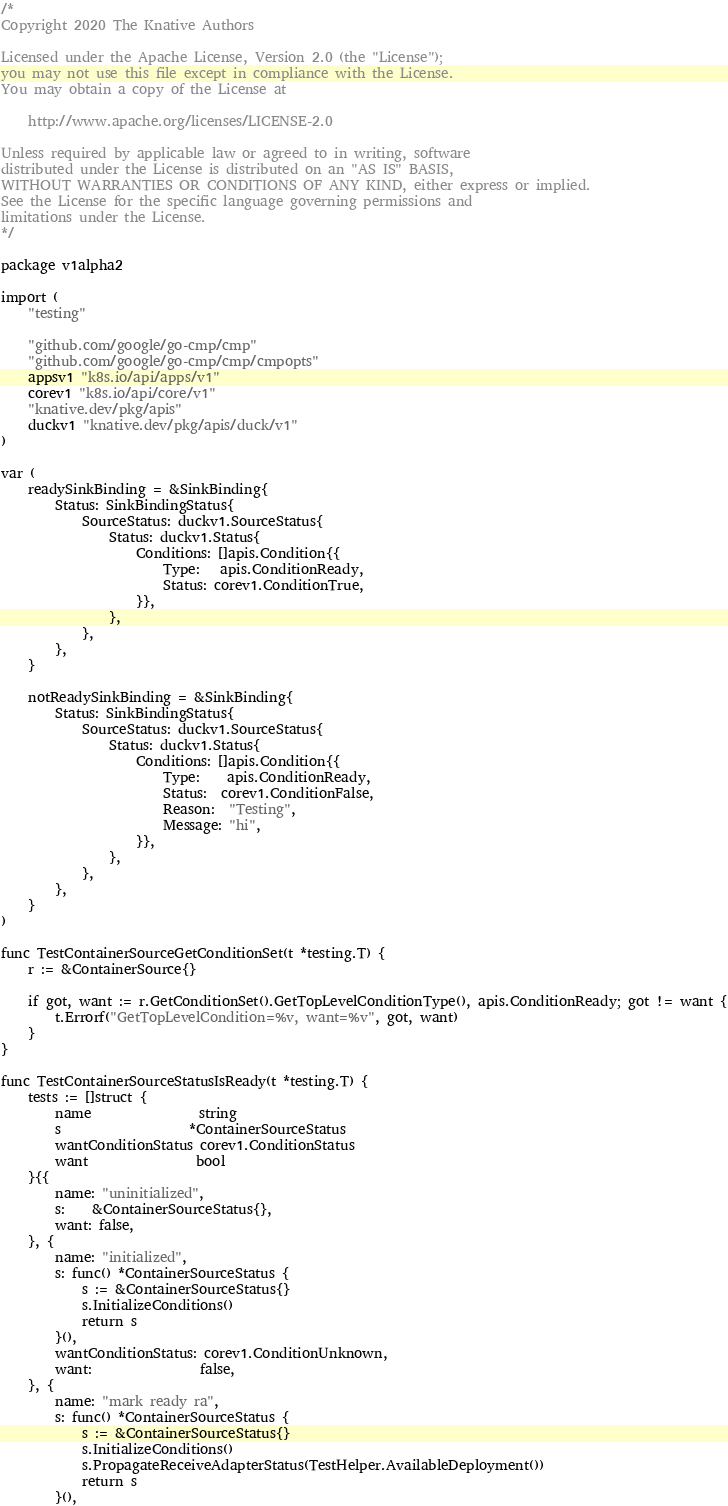<code> <loc_0><loc_0><loc_500><loc_500><_Go_>/*
Copyright 2020 The Knative Authors

Licensed under the Apache License, Version 2.0 (the "License");
you may not use this file except in compliance with the License.
You may obtain a copy of the License at

    http://www.apache.org/licenses/LICENSE-2.0

Unless required by applicable law or agreed to in writing, software
distributed under the License is distributed on an "AS IS" BASIS,
WITHOUT WARRANTIES OR CONDITIONS OF ANY KIND, either express or implied.
See the License for the specific language governing permissions and
limitations under the License.
*/

package v1alpha2

import (
	"testing"

	"github.com/google/go-cmp/cmp"
	"github.com/google/go-cmp/cmp/cmpopts"
	appsv1 "k8s.io/api/apps/v1"
	corev1 "k8s.io/api/core/v1"
	"knative.dev/pkg/apis"
	duckv1 "knative.dev/pkg/apis/duck/v1"
)

var (
	readySinkBinding = &SinkBinding{
		Status: SinkBindingStatus{
			SourceStatus: duckv1.SourceStatus{
				Status: duckv1.Status{
					Conditions: []apis.Condition{{
						Type:   apis.ConditionReady,
						Status: corev1.ConditionTrue,
					}},
				},
			},
		},
	}

	notReadySinkBinding = &SinkBinding{
		Status: SinkBindingStatus{
			SourceStatus: duckv1.SourceStatus{
				Status: duckv1.Status{
					Conditions: []apis.Condition{{
						Type:    apis.ConditionReady,
						Status:  corev1.ConditionFalse,
						Reason:  "Testing",
						Message: "hi",
					}},
				},
			},
		},
	}
)

func TestContainerSourceGetConditionSet(t *testing.T) {
	r := &ContainerSource{}

	if got, want := r.GetConditionSet().GetTopLevelConditionType(), apis.ConditionReady; got != want {
		t.Errorf("GetTopLevelCondition=%v, want=%v", got, want)
	}
}

func TestContainerSourceStatusIsReady(t *testing.T) {
	tests := []struct {
		name                string
		s                   *ContainerSourceStatus
		wantConditionStatus corev1.ConditionStatus
		want                bool
	}{{
		name: "uninitialized",
		s:    &ContainerSourceStatus{},
		want: false,
	}, {
		name: "initialized",
		s: func() *ContainerSourceStatus {
			s := &ContainerSourceStatus{}
			s.InitializeConditions()
			return s
		}(),
		wantConditionStatus: corev1.ConditionUnknown,
		want:                false,
	}, {
		name: "mark ready ra",
		s: func() *ContainerSourceStatus {
			s := &ContainerSourceStatus{}
			s.InitializeConditions()
			s.PropagateReceiveAdapterStatus(TestHelper.AvailableDeployment())
			return s
		}(),</code> 